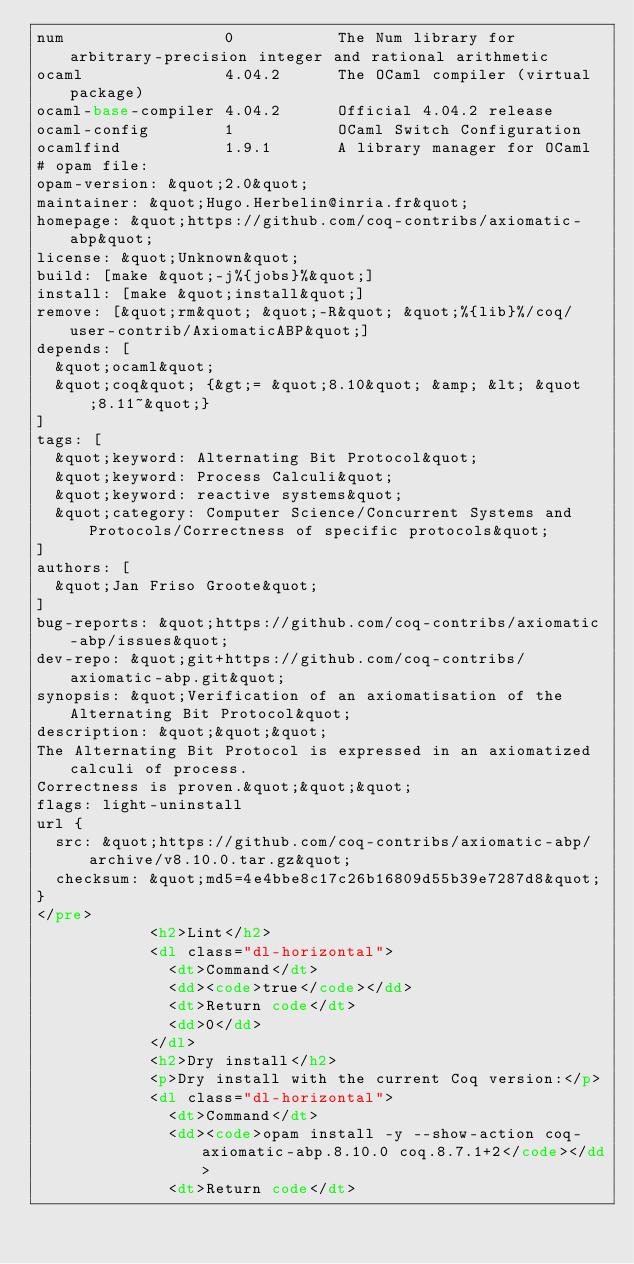<code> <loc_0><loc_0><loc_500><loc_500><_HTML_>num                 0           The Num library for arbitrary-precision integer and rational arithmetic
ocaml               4.04.2      The OCaml compiler (virtual package)
ocaml-base-compiler 4.04.2      Official 4.04.2 release
ocaml-config        1           OCaml Switch Configuration
ocamlfind           1.9.1       A library manager for OCaml
# opam file:
opam-version: &quot;2.0&quot;
maintainer: &quot;Hugo.Herbelin@inria.fr&quot;
homepage: &quot;https://github.com/coq-contribs/axiomatic-abp&quot;
license: &quot;Unknown&quot;
build: [make &quot;-j%{jobs}%&quot;]
install: [make &quot;install&quot;]
remove: [&quot;rm&quot; &quot;-R&quot; &quot;%{lib}%/coq/user-contrib/AxiomaticABP&quot;]
depends: [
  &quot;ocaml&quot;
  &quot;coq&quot; {&gt;= &quot;8.10&quot; &amp; &lt; &quot;8.11~&quot;}
]
tags: [
  &quot;keyword: Alternating Bit Protocol&quot;
  &quot;keyword: Process Calculi&quot;
  &quot;keyword: reactive systems&quot;
  &quot;category: Computer Science/Concurrent Systems and Protocols/Correctness of specific protocols&quot;
]
authors: [
  &quot;Jan Friso Groote&quot;
]
bug-reports: &quot;https://github.com/coq-contribs/axiomatic-abp/issues&quot;
dev-repo: &quot;git+https://github.com/coq-contribs/axiomatic-abp.git&quot;
synopsis: &quot;Verification of an axiomatisation of the Alternating Bit Protocol&quot;
description: &quot;&quot;&quot;
The Alternating Bit Protocol is expressed in an axiomatized calculi of process.
Correctness is proven.&quot;&quot;&quot;
flags: light-uninstall
url {
  src: &quot;https://github.com/coq-contribs/axiomatic-abp/archive/v8.10.0.tar.gz&quot;
  checksum: &quot;md5=4e4bbe8c17c26b16809d55b39e7287d8&quot;
}
</pre>
            <h2>Lint</h2>
            <dl class="dl-horizontal">
              <dt>Command</dt>
              <dd><code>true</code></dd>
              <dt>Return code</dt>
              <dd>0</dd>
            </dl>
            <h2>Dry install</h2>
            <p>Dry install with the current Coq version:</p>
            <dl class="dl-horizontal">
              <dt>Command</dt>
              <dd><code>opam install -y --show-action coq-axiomatic-abp.8.10.0 coq.8.7.1+2</code></dd>
              <dt>Return code</dt></code> 